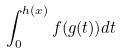<formula> <loc_0><loc_0><loc_500><loc_500>\int _ { 0 } ^ { h ( x ) } f ( g ( t ) ) d t</formula> 